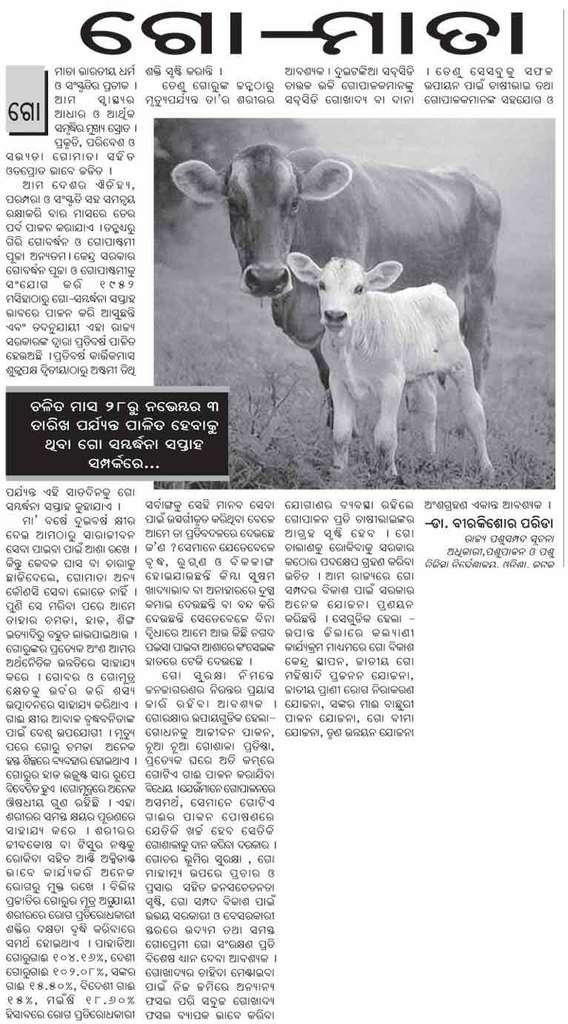What is present in the image that contains visual information? There is a poster in the image that contains images. What else can be found on the poster besides images? The poster contains text as well. What type of glove is depicted in the poster? There is no glove present in the poster; it contains images and text, but no gloves. 